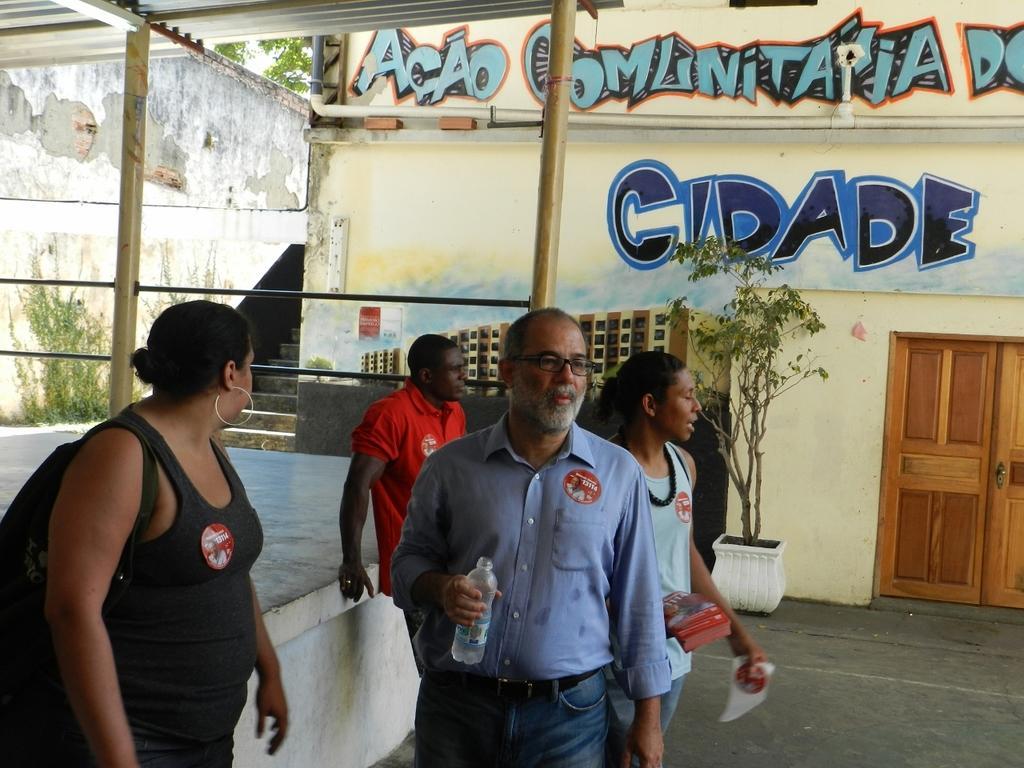How would you summarize this image in a sentence or two? In this picture we can see there are four people standing on the path and a man is holding a bottle and another person holding some objects. On the left side of the people there are poles and iron grills and at the top there are iron sheets. Behind the people there is a house plant in the pot, a wall with a door, pipe and some paintings. On the left side of the building there are steps, wall, trees and the sky. 